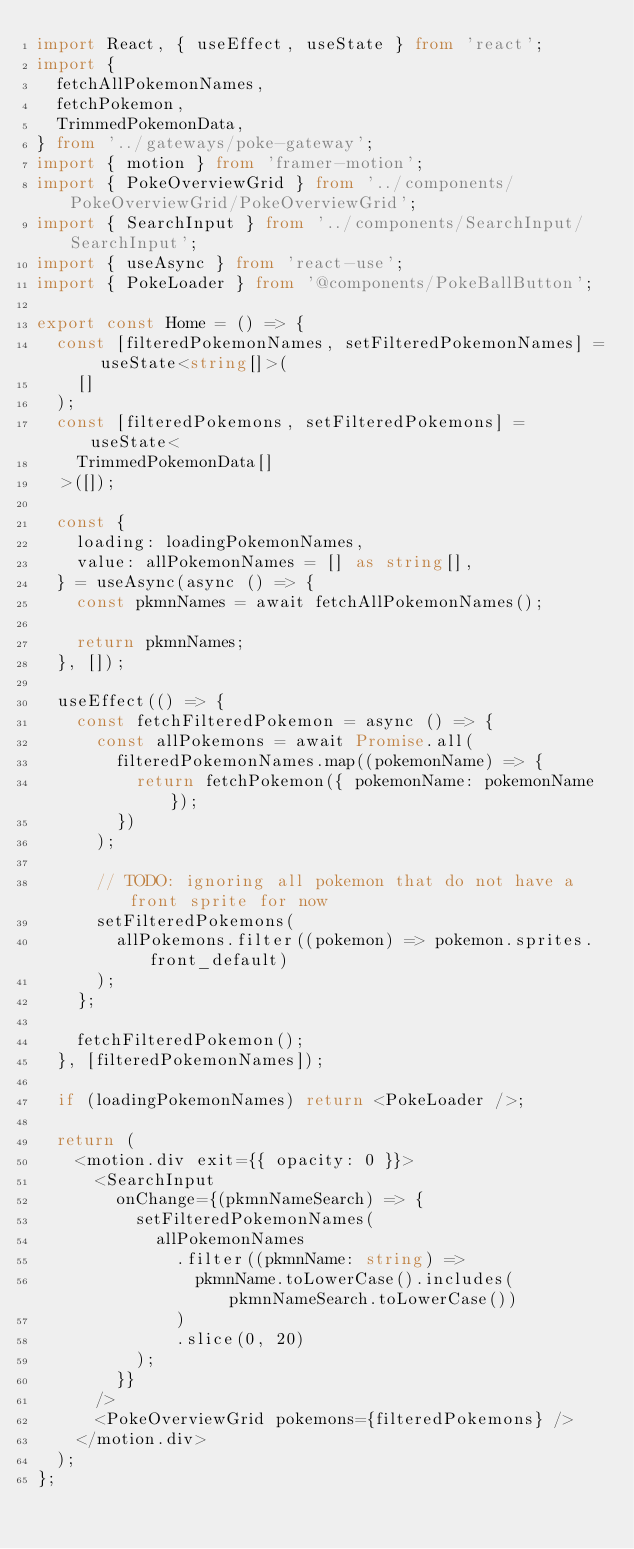<code> <loc_0><loc_0><loc_500><loc_500><_TypeScript_>import React, { useEffect, useState } from 'react';
import {
  fetchAllPokemonNames,
  fetchPokemon,
  TrimmedPokemonData,
} from '../gateways/poke-gateway';
import { motion } from 'framer-motion';
import { PokeOverviewGrid } from '../components/PokeOverviewGrid/PokeOverviewGrid';
import { SearchInput } from '../components/SearchInput/SearchInput';
import { useAsync } from 'react-use';
import { PokeLoader } from '@components/PokeBallButton';

export const Home = () => {
  const [filteredPokemonNames, setFilteredPokemonNames] = useState<string[]>(
    []
  );
  const [filteredPokemons, setFilteredPokemons] = useState<
    TrimmedPokemonData[]
  >([]);

  const {
    loading: loadingPokemonNames,
    value: allPokemonNames = [] as string[],
  } = useAsync(async () => {
    const pkmnNames = await fetchAllPokemonNames();

    return pkmnNames;
  }, []);

  useEffect(() => {
    const fetchFilteredPokemon = async () => {
      const allPokemons = await Promise.all(
        filteredPokemonNames.map((pokemonName) => {
          return fetchPokemon({ pokemonName: pokemonName });
        })
      );

      // TODO: ignoring all pokemon that do not have a front sprite for now
      setFilteredPokemons(
        allPokemons.filter((pokemon) => pokemon.sprites.front_default)
      );
    };

    fetchFilteredPokemon();
  }, [filteredPokemonNames]);

  if (loadingPokemonNames) return <PokeLoader />;

  return (
    <motion.div exit={{ opacity: 0 }}>
      <SearchInput
        onChange={(pkmnNameSearch) => {
          setFilteredPokemonNames(
            allPokemonNames
              .filter((pkmnName: string) =>
                pkmnName.toLowerCase().includes(pkmnNameSearch.toLowerCase())
              )
              .slice(0, 20)
          );
        }}
      />
      <PokeOverviewGrid pokemons={filteredPokemons} />
    </motion.div>
  );
};
</code> 